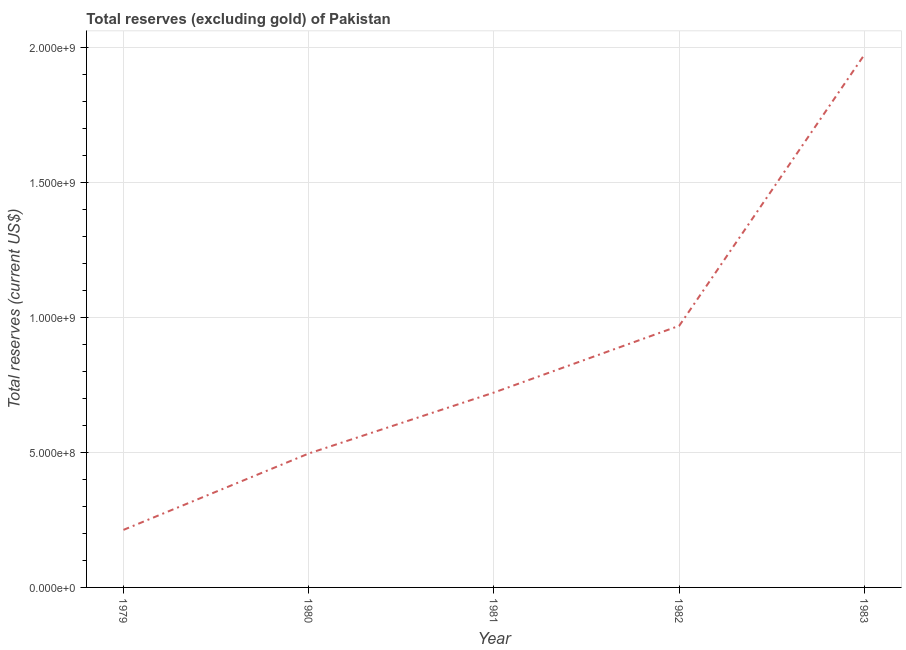What is the total reserves (excluding gold) in 1983?
Offer a very short reply. 1.97e+09. Across all years, what is the maximum total reserves (excluding gold)?
Your answer should be very brief. 1.97e+09. Across all years, what is the minimum total reserves (excluding gold)?
Give a very brief answer. 2.13e+08. In which year was the total reserves (excluding gold) maximum?
Give a very brief answer. 1983. In which year was the total reserves (excluding gold) minimum?
Ensure brevity in your answer.  1979. What is the sum of the total reserves (excluding gold)?
Your answer should be very brief. 4.37e+09. What is the difference between the total reserves (excluding gold) in 1979 and 1980?
Make the answer very short. -2.83e+08. What is the average total reserves (excluding gold) per year?
Offer a very short reply. 8.74e+08. What is the median total reserves (excluding gold)?
Your answer should be compact. 7.21e+08. In how many years, is the total reserves (excluding gold) greater than 300000000 US$?
Ensure brevity in your answer.  4. Do a majority of the years between 1979 and 1980 (inclusive) have total reserves (excluding gold) greater than 1200000000 US$?
Keep it short and to the point. No. What is the ratio of the total reserves (excluding gold) in 1979 to that in 1982?
Keep it short and to the point. 0.22. What is the difference between the highest and the second highest total reserves (excluding gold)?
Keep it short and to the point. 1.00e+09. Is the sum of the total reserves (excluding gold) in 1979 and 1981 greater than the maximum total reserves (excluding gold) across all years?
Make the answer very short. No. What is the difference between the highest and the lowest total reserves (excluding gold)?
Your answer should be compact. 1.76e+09. Does the total reserves (excluding gold) monotonically increase over the years?
Your response must be concise. Yes. How many lines are there?
Provide a succinct answer. 1. What is the difference between two consecutive major ticks on the Y-axis?
Give a very brief answer. 5.00e+08. Does the graph contain any zero values?
Your answer should be compact. No. Does the graph contain grids?
Give a very brief answer. Yes. What is the title of the graph?
Provide a short and direct response. Total reserves (excluding gold) of Pakistan. What is the label or title of the X-axis?
Offer a terse response. Year. What is the label or title of the Y-axis?
Offer a terse response. Total reserves (current US$). What is the Total reserves (current US$) of 1979?
Keep it short and to the point. 2.13e+08. What is the Total reserves (current US$) in 1980?
Offer a terse response. 4.96e+08. What is the Total reserves (current US$) of 1981?
Offer a very short reply. 7.21e+08. What is the Total reserves (current US$) of 1982?
Ensure brevity in your answer.  9.69e+08. What is the Total reserves (current US$) of 1983?
Offer a very short reply. 1.97e+09. What is the difference between the Total reserves (current US$) in 1979 and 1980?
Offer a very short reply. -2.83e+08. What is the difference between the Total reserves (current US$) in 1979 and 1981?
Provide a short and direct response. -5.08e+08. What is the difference between the Total reserves (current US$) in 1979 and 1982?
Your answer should be compact. -7.55e+08. What is the difference between the Total reserves (current US$) in 1979 and 1983?
Keep it short and to the point. -1.76e+09. What is the difference between the Total reserves (current US$) in 1980 and 1981?
Your answer should be compact. -2.26e+08. What is the difference between the Total reserves (current US$) in 1980 and 1982?
Offer a terse response. -4.73e+08. What is the difference between the Total reserves (current US$) in 1980 and 1983?
Offer a terse response. -1.48e+09. What is the difference between the Total reserves (current US$) in 1981 and 1982?
Offer a very short reply. -2.47e+08. What is the difference between the Total reserves (current US$) in 1981 and 1983?
Ensure brevity in your answer.  -1.25e+09. What is the difference between the Total reserves (current US$) in 1982 and 1983?
Keep it short and to the point. -1.00e+09. What is the ratio of the Total reserves (current US$) in 1979 to that in 1980?
Your answer should be compact. 0.43. What is the ratio of the Total reserves (current US$) in 1979 to that in 1981?
Your response must be concise. 0.29. What is the ratio of the Total reserves (current US$) in 1979 to that in 1982?
Your answer should be very brief. 0.22. What is the ratio of the Total reserves (current US$) in 1979 to that in 1983?
Ensure brevity in your answer.  0.11. What is the ratio of the Total reserves (current US$) in 1980 to that in 1981?
Provide a short and direct response. 0.69. What is the ratio of the Total reserves (current US$) in 1980 to that in 1982?
Your answer should be compact. 0.51. What is the ratio of the Total reserves (current US$) in 1980 to that in 1983?
Your answer should be compact. 0.25. What is the ratio of the Total reserves (current US$) in 1981 to that in 1982?
Keep it short and to the point. 0.74. What is the ratio of the Total reserves (current US$) in 1981 to that in 1983?
Provide a succinct answer. 0.37. What is the ratio of the Total reserves (current US$) in 1982 to that in 1983?
Provide a succinct answer. 0.49. 